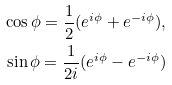<formula> <loc_0><loc_0><loc_500><loc_500>\cos \phi = \frac { 1 } { 2 } ( e ^ { i \phi } + e ^ { - i \phi } ) , \\ \sin \phi = \frac { 1 } { 2 i } ( e ^ { i \phi } - e ^ { - i \phi } )</formula> 